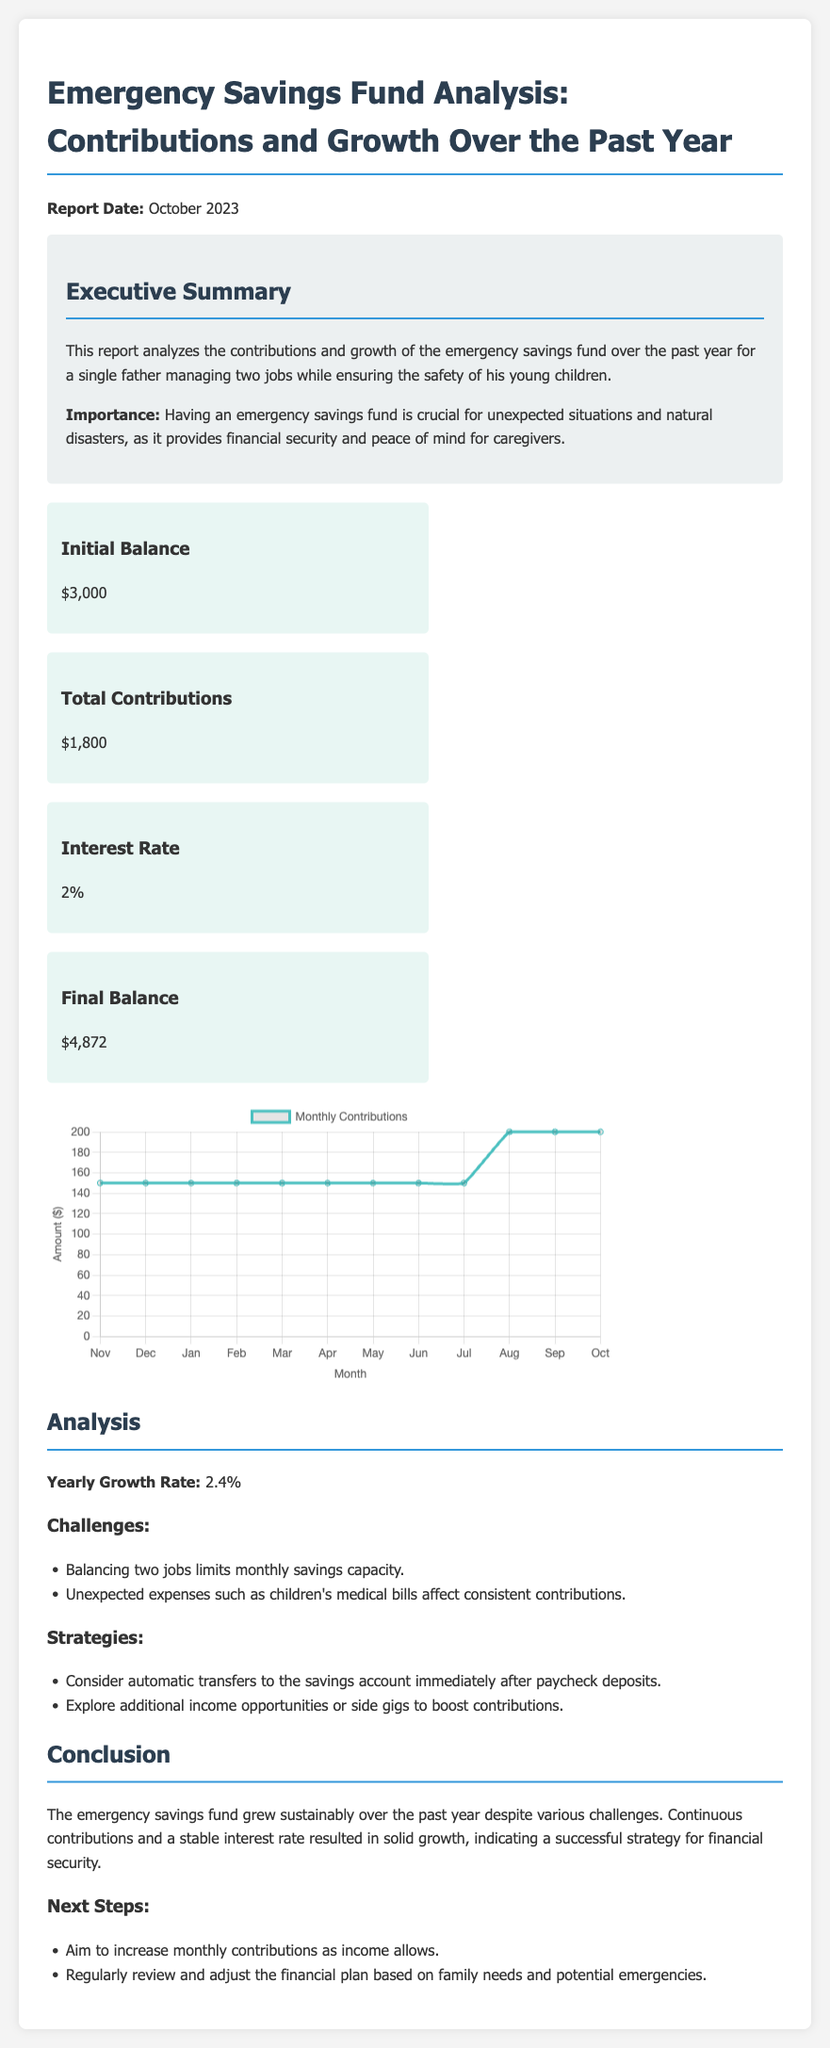What is the report date? The report date is stated at the beginning of the document.
Answer: October 2023 What was the initial balance of the emergency savings fund? The initial balance is presented as a specific amount in the fund performance section.
Answer: $3,000 What was the total amount of contributions made over the past year? The total contributions figure is included within the fund performance details.
Answer: $1,800 What is the final balance of the emergency savings fund? The final balance is provided in the fund performance section as a key figure.
Answer: $4,872 What is the yearly growth rate of the emergency savings fund? The yearly growth rate is mentioned directly in the analysis section of the report.
Answer: 2.4% What challenges are mentioned regarding savings contributions? Challenges faced in maintaining contributions are listed in the analysis section.
Answer: Balancing two jobs limits monthly savings capacity What strategies are suggested to increase contributions? Suggested strategies for improving contributions are found in the analysis section.
Answer: Consider automatic transfers to the savings account What is the main purpose of having an emergency savings fund according to the report? The importance of an emergency savings fund is highlighted in the executive summary.
Answer: Provides financial security and peace of mind for caregivers What are the next steps proposed in the conclusion? The conclusion outlines future actions to take regarding contributions.
Answer: Aim to increase monthly contributions as income allows 